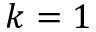<formula> <loc_0><loc_0><loc_500><loc_500>k = 1</formula> 